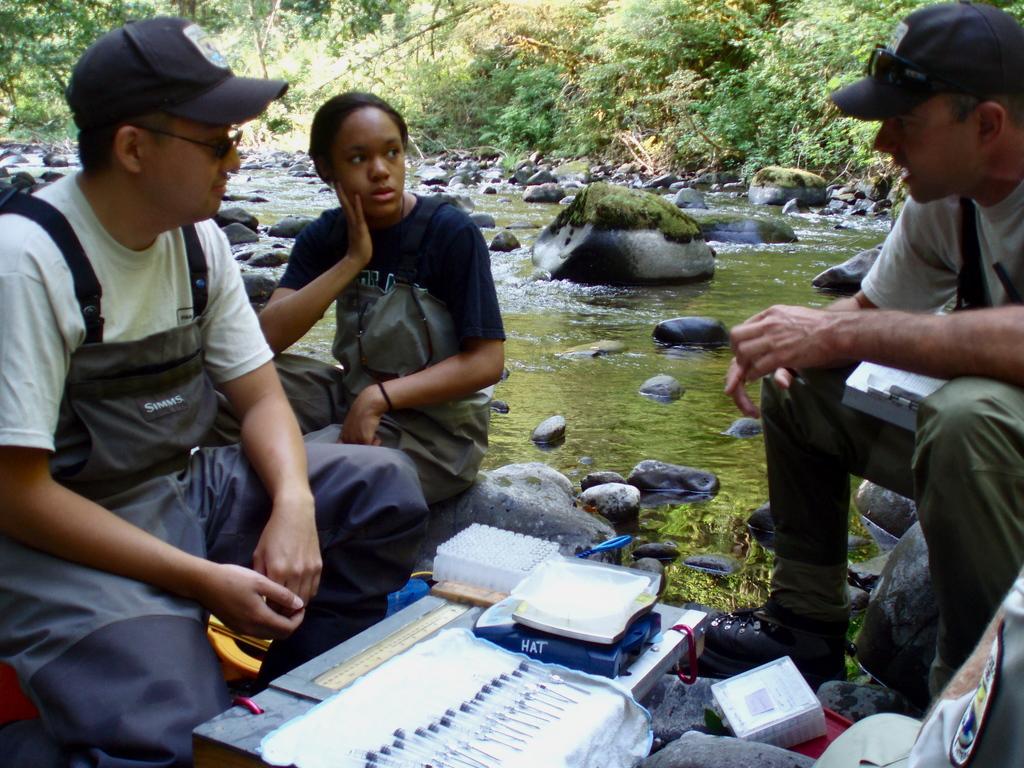Could you give a brief overview of what you see in this image? In this image we can see few people sitting, beside that we can see medical devices on the table, beside that we can see water and stones. And we can see the trees and plants. 